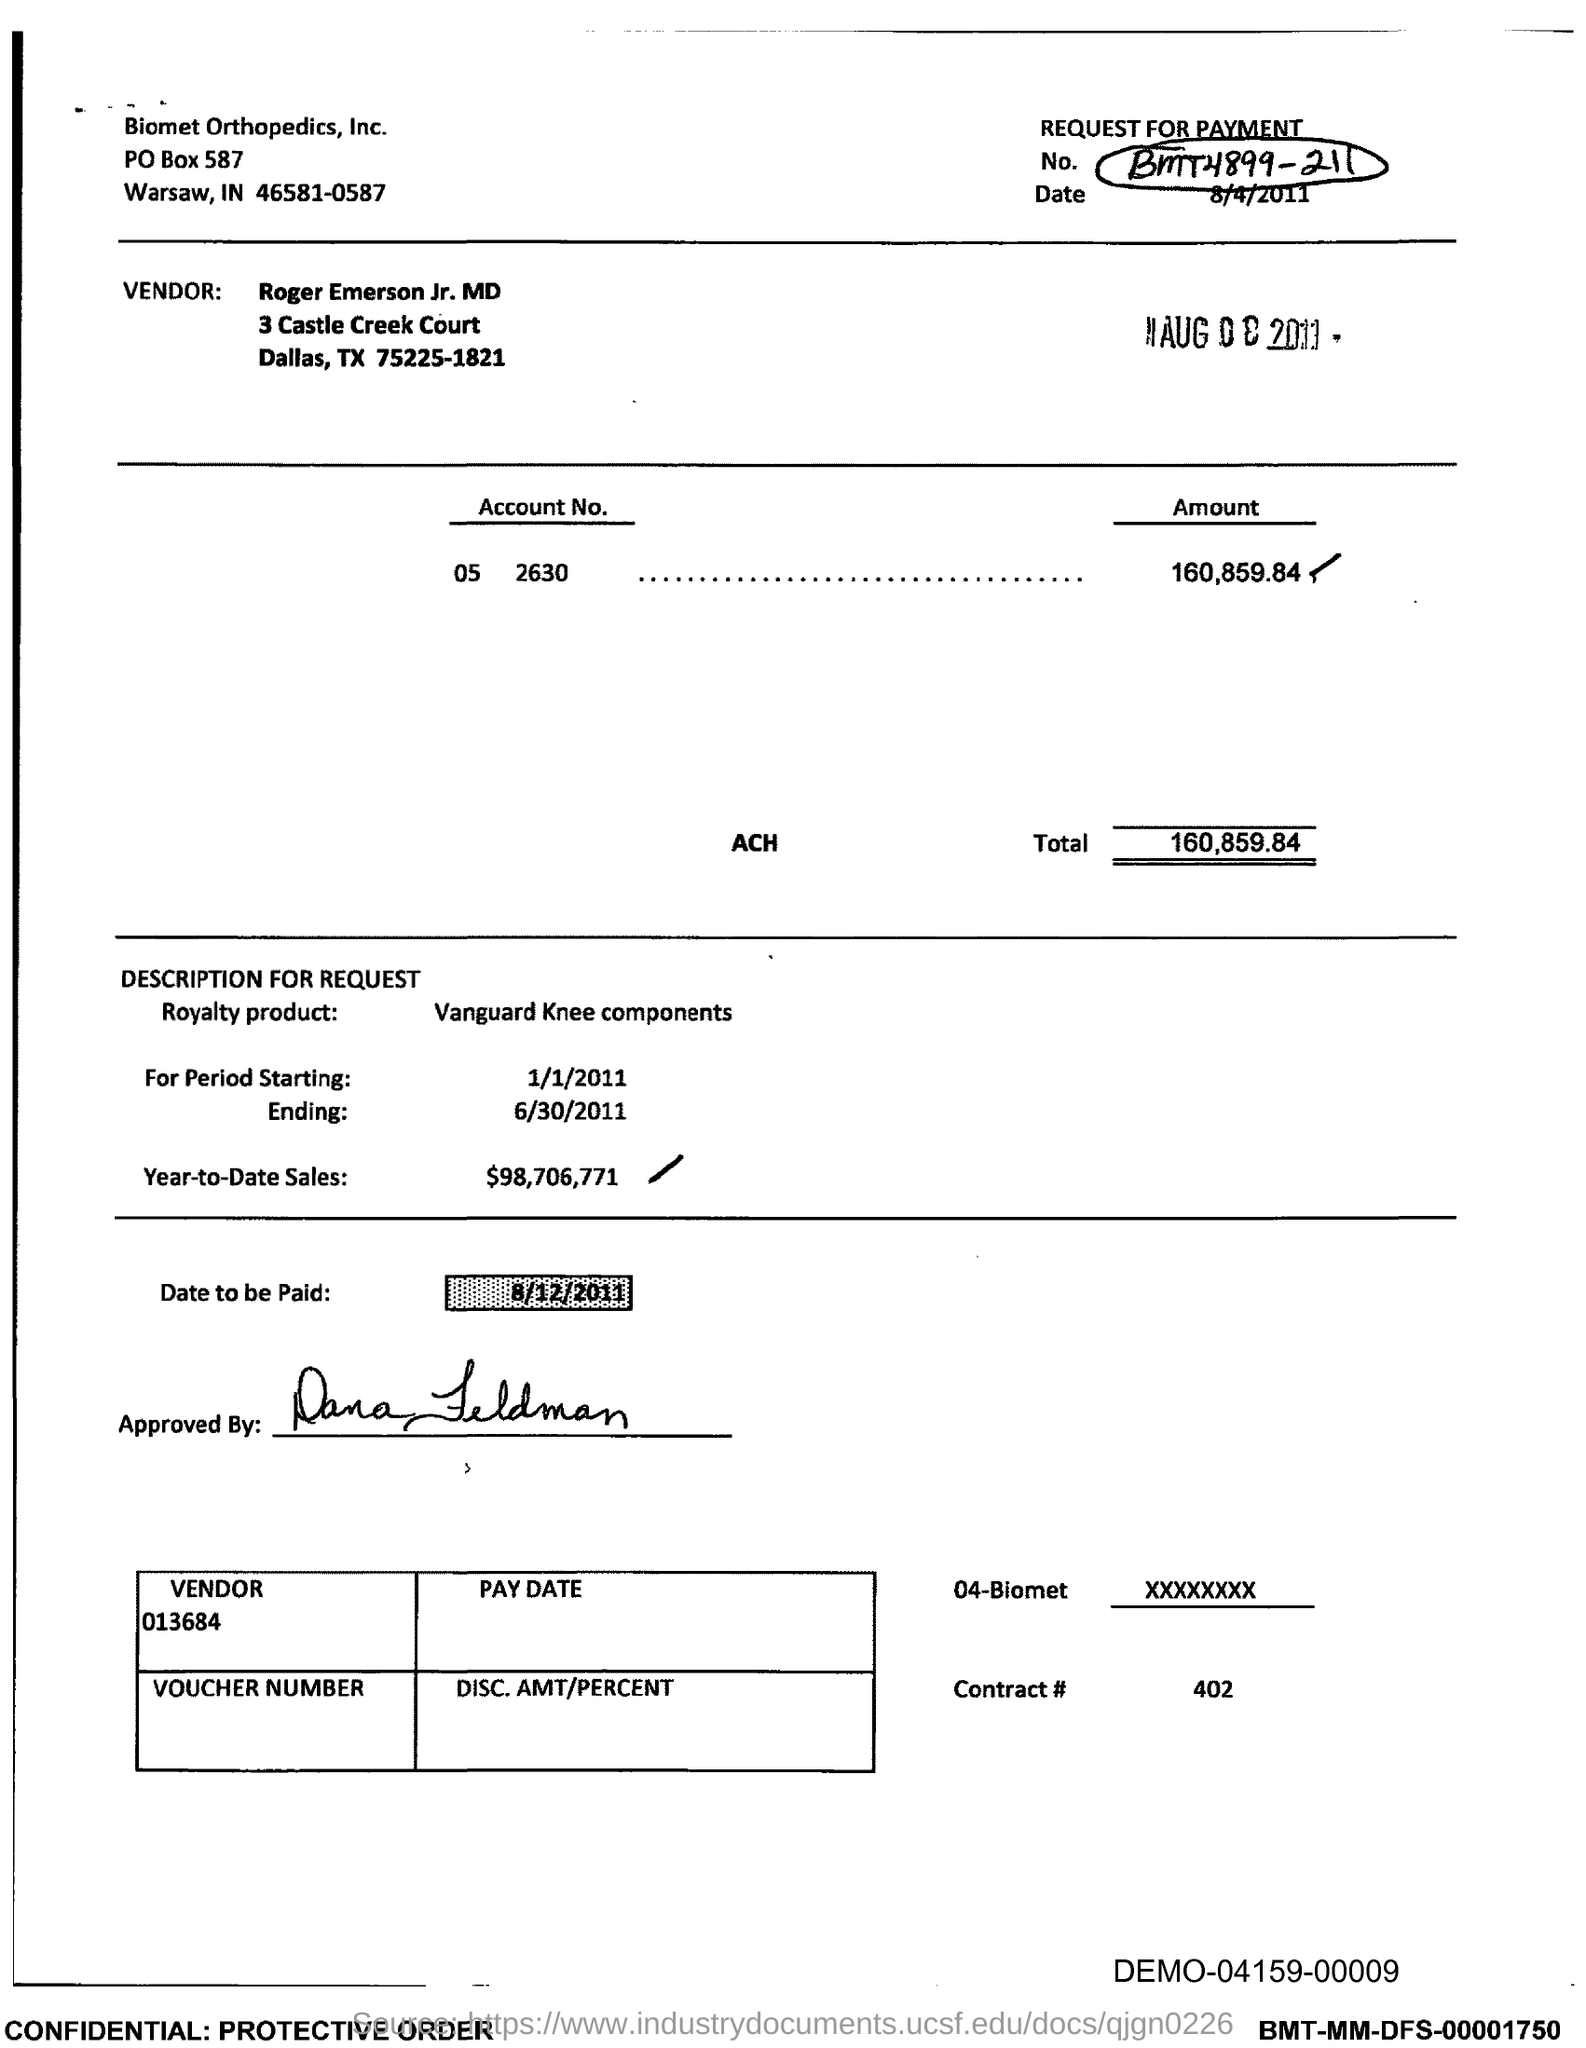What is the Contract # Number?
Provide a succinct answer. 402. What is the Total?
Your response must be concise. 160,859.84. What is the Year-to-Date-Sales?
Provide a short and direct response. $98,706,771. 